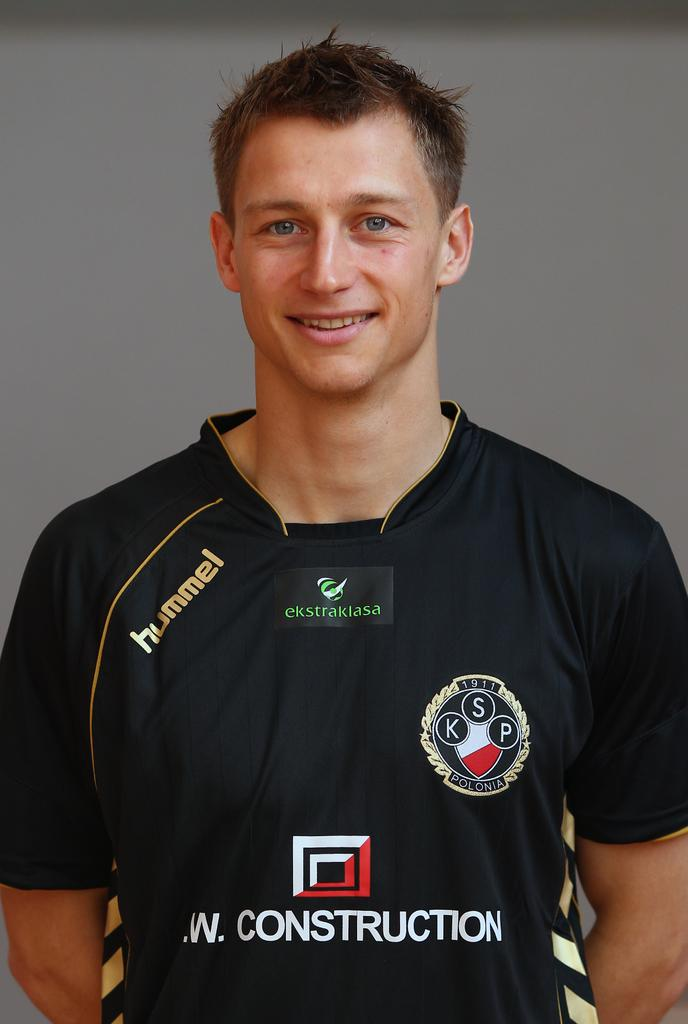<image>
Describe the image concisely. A man poses for a photo while wearing a shirt with the sponsors hummel, ekstraklasa, and .W. Construction on it. 